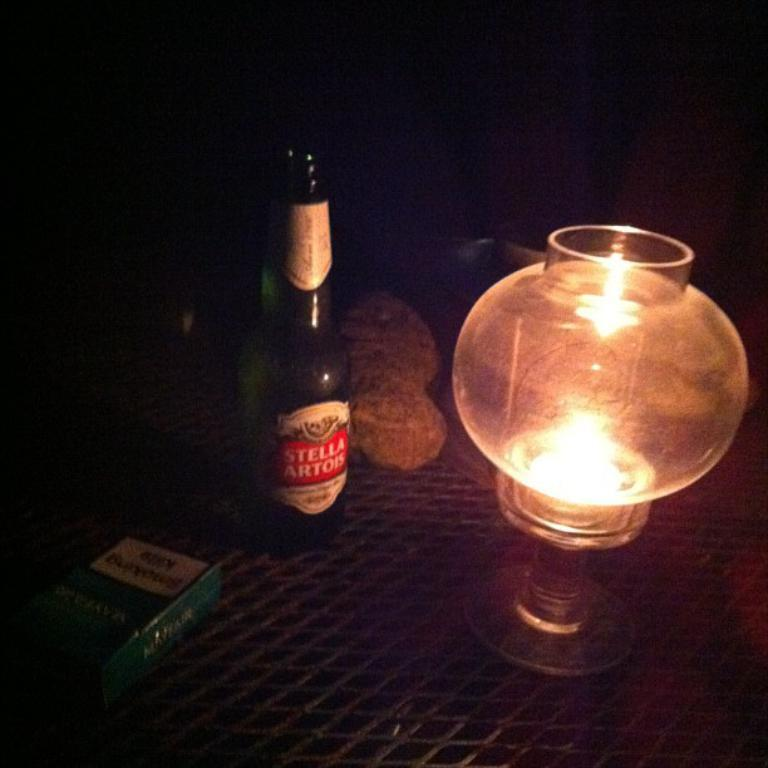<image>
Share a concise interpretation of the image provided. An open bottle of Stella Artois on a table next to a pack of cigarettes and a light. 